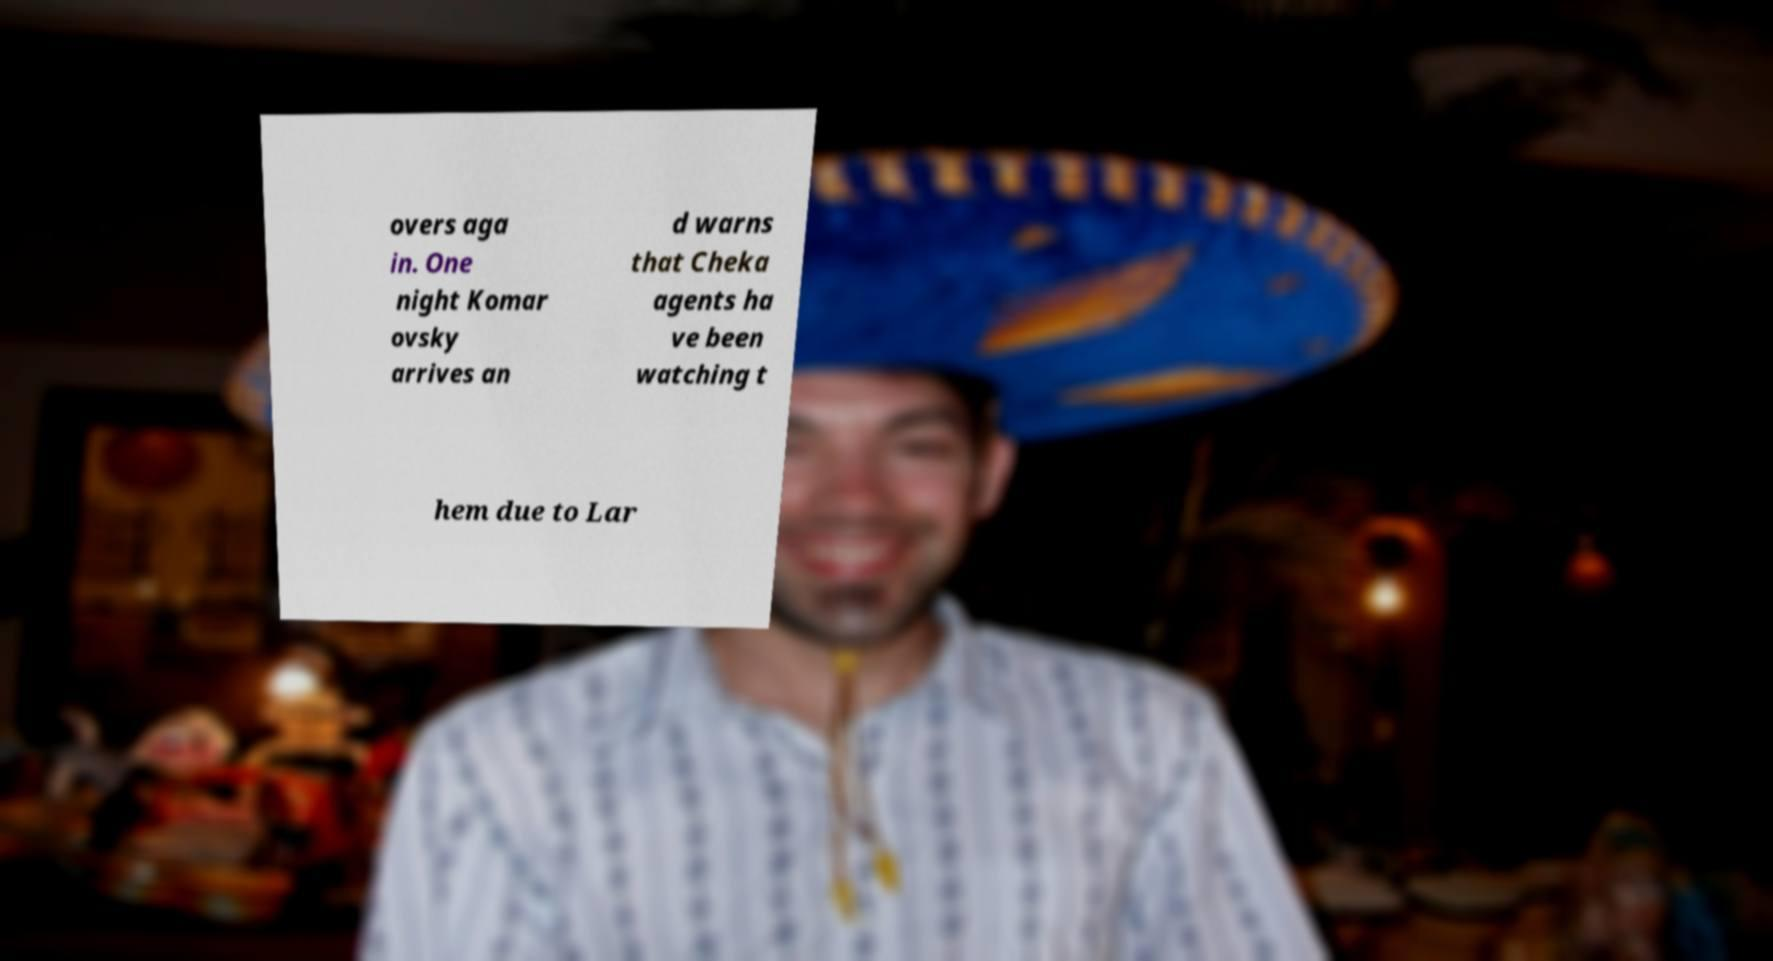There's text embedded in this image that I need extracted. Can you transcribe it verbatim? overs aga in. One night Komar ovsky arrives an d warns that Cheka agents ha ve been watching t hem due to Lar 